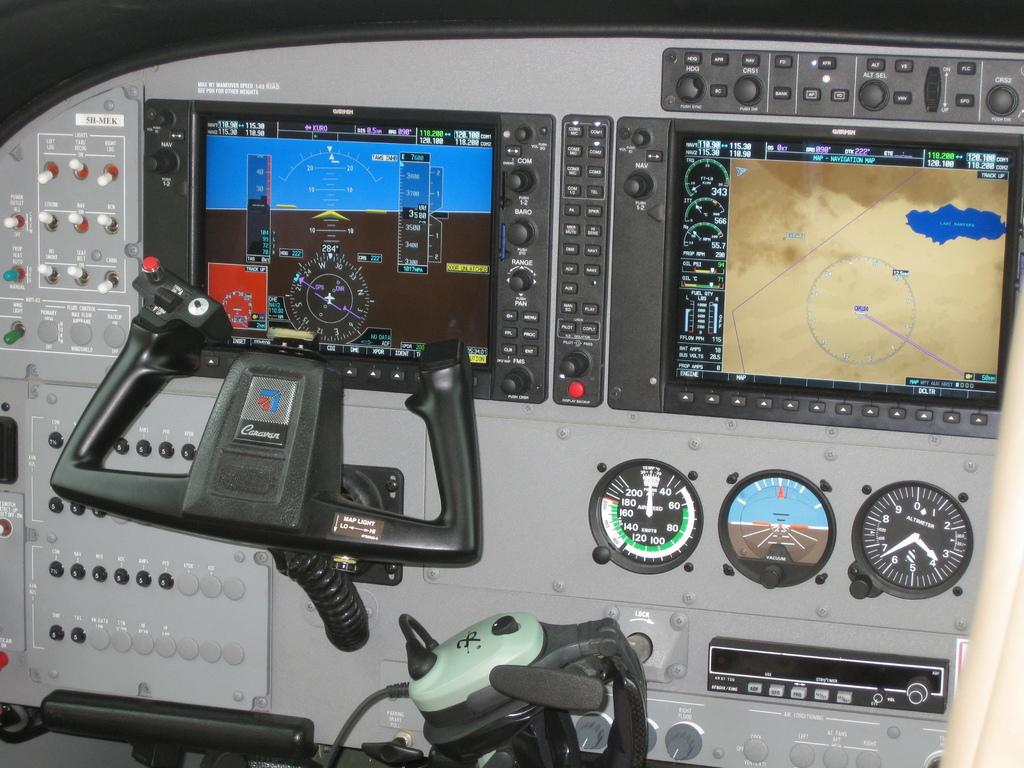<image>
Provide a brief description of the given image. Airplane cockpit showing a steering wheel which says Caravan on it. 